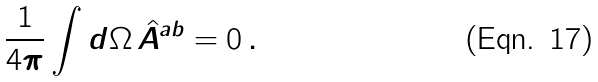Convert formula to latex. <formula><loc_0><loc_0><loc_500><loc_500>\frac { 1 } { 4 \pi } \int d \Omega \, \hat { A } ^ { a b } = 0 \, .</formula> 